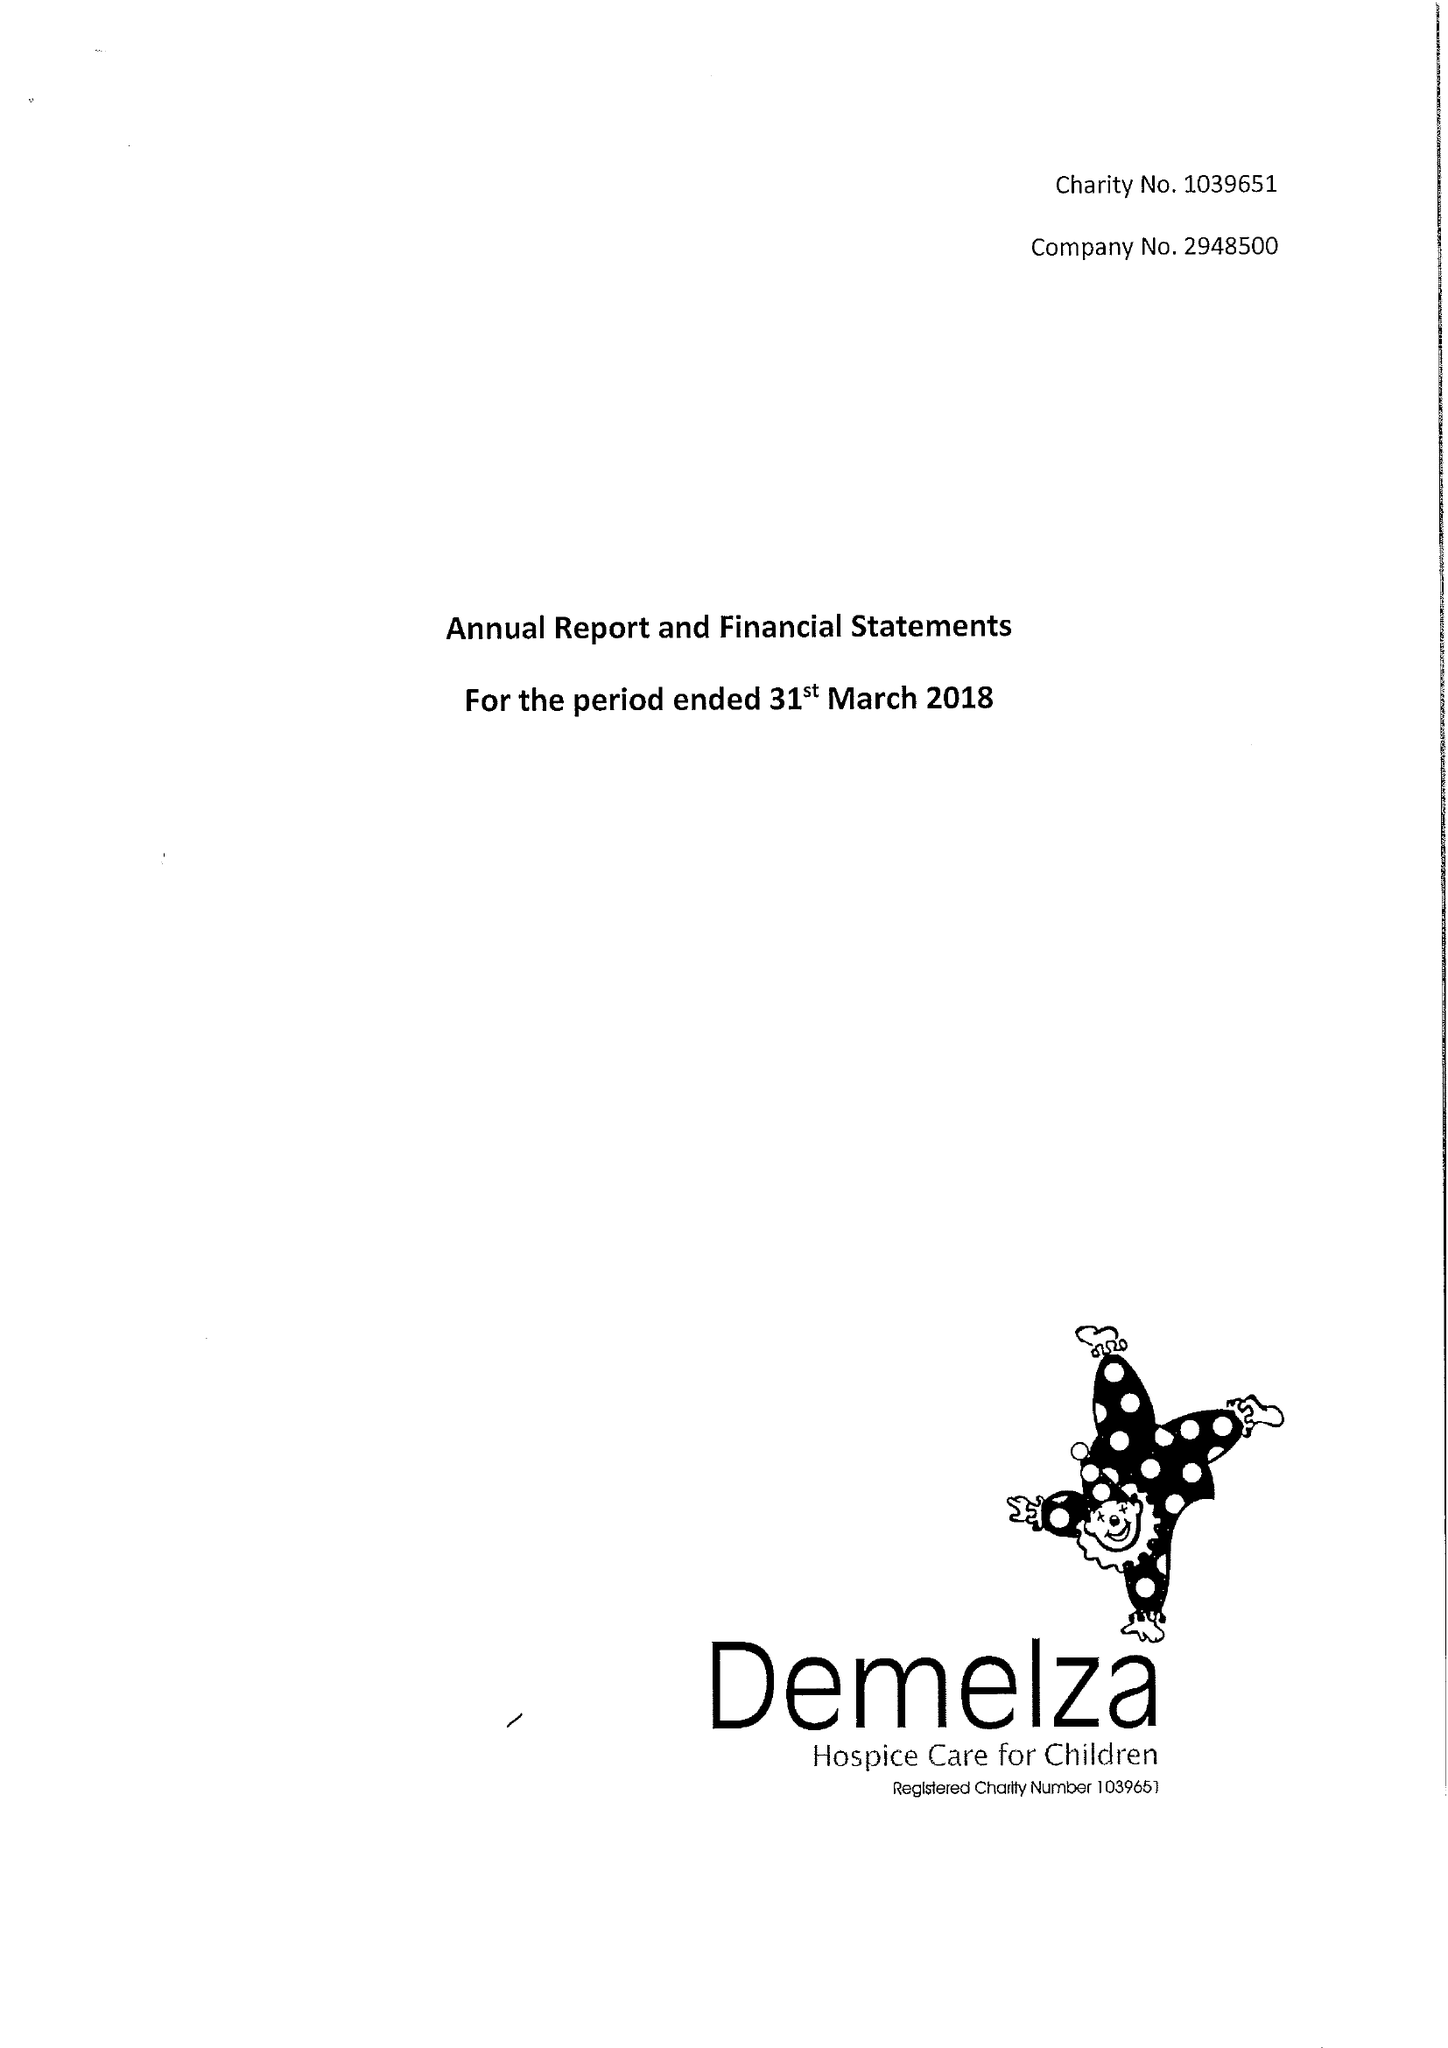What is the value for the charity_name?
Answer the question using a single word or phrase. Demelza House Childrens Hospice 